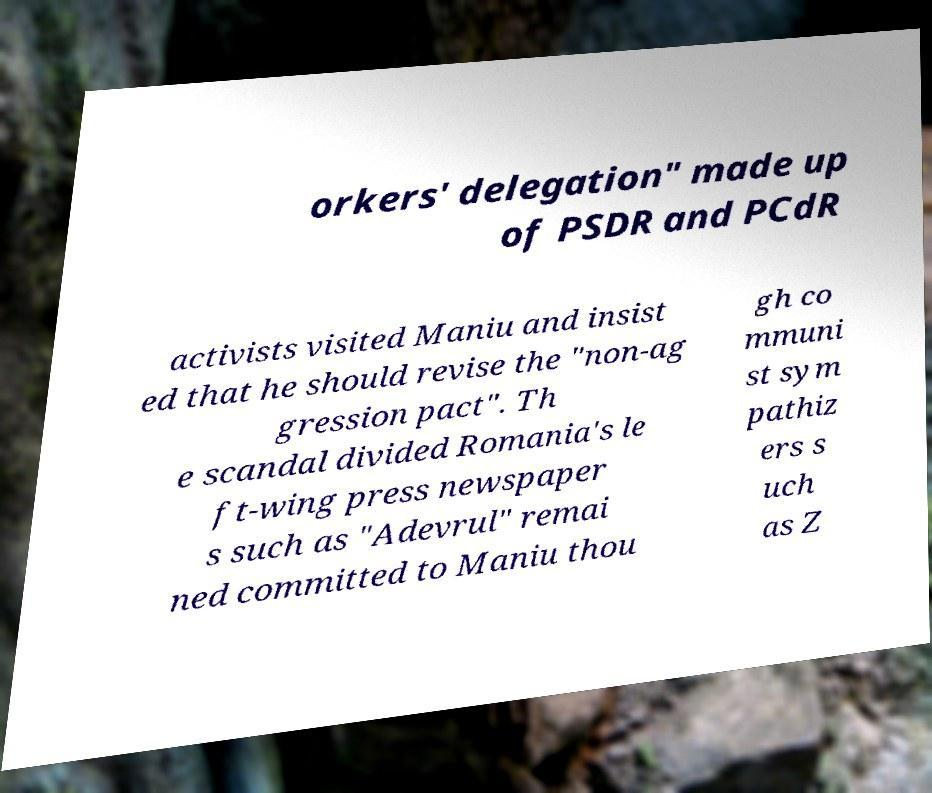Can you accurately transcribe the text from the provided image for me? orkers' delegation" made up of PSDR and PCdR activists visited Maniu and insist ed that he should revise the "non-ag gression pact". Th e scandal divided Romania's le ft-wing press newspaper s such as "Adevrul" remai ned committed to Maniu thou gh co mmuni st sym pathiz ers s uch as Z 